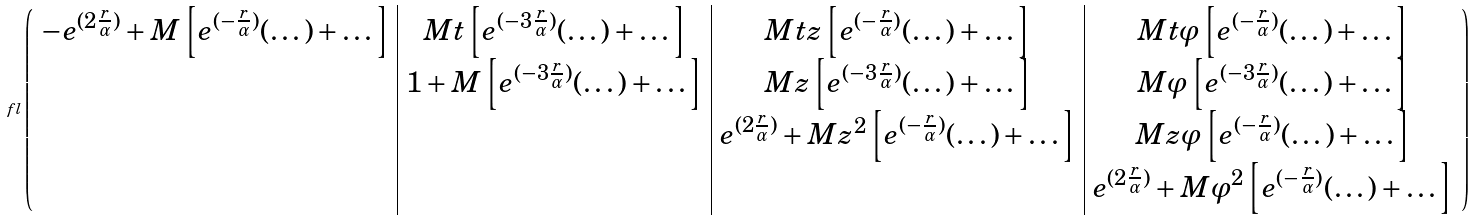<formula> <loc_0><loc_0><loc_500><loc_500>\ f l \left ( \begin{array} { c | c | c | c } - e ^ { ( 2 \frac { r } { \alpha } ) } + M \left [ e ^ { ( - \frac { r } { \alpha } ) } ( \dots ) + \dots \right ] & M t \left [ e ^ { ( - 3 \frac { r } { \alpha } ) } ( \dots ) + \dots \right ] & M t z \left [ e ^ { ( - \frac { r } { \alpha } ) } ( \dots ) + \dots \right ] & M t \varphi \left [ e ^ { ( - \frac { r } { \alpha } ) } ( \dots ) + \dots \right ] \\ & 1 + M \left [ e ^ { ( - 3 \frac { r } { \alpha } ) } ( \dots ) + \dots \right ] & M z \left [ e ^ { ( - 3 \frac { r } { \alpha } ) } ( \dots ) + \dots \right ] & M \varphi \left [ e ^ { ( - 3 \frac { r } { \alpha } ) } ( \dots ) + \dots \right ] \\ & & e ^ { ( 2 \frac { r } { \alpha } ) } + M z ^ { 2 } \left [ e ^ { ( - \frac { r } { \alpha } ) } ( \dots ) + \dots \right ] & M z \varphi \left [ e ^ { ( - \frac { r } { \alpha } ) } ( \dots ) + \dots \right ] \\ & & & e ^ { ( 2 \frac { r } { \alpha } ) } + M \varphi ^ { 2 } \left [ e ^ { ( - \frac { r } { \alpha } ) } ( \dots ) + \dots \right ] \\ \end{array} \right )</formula> 